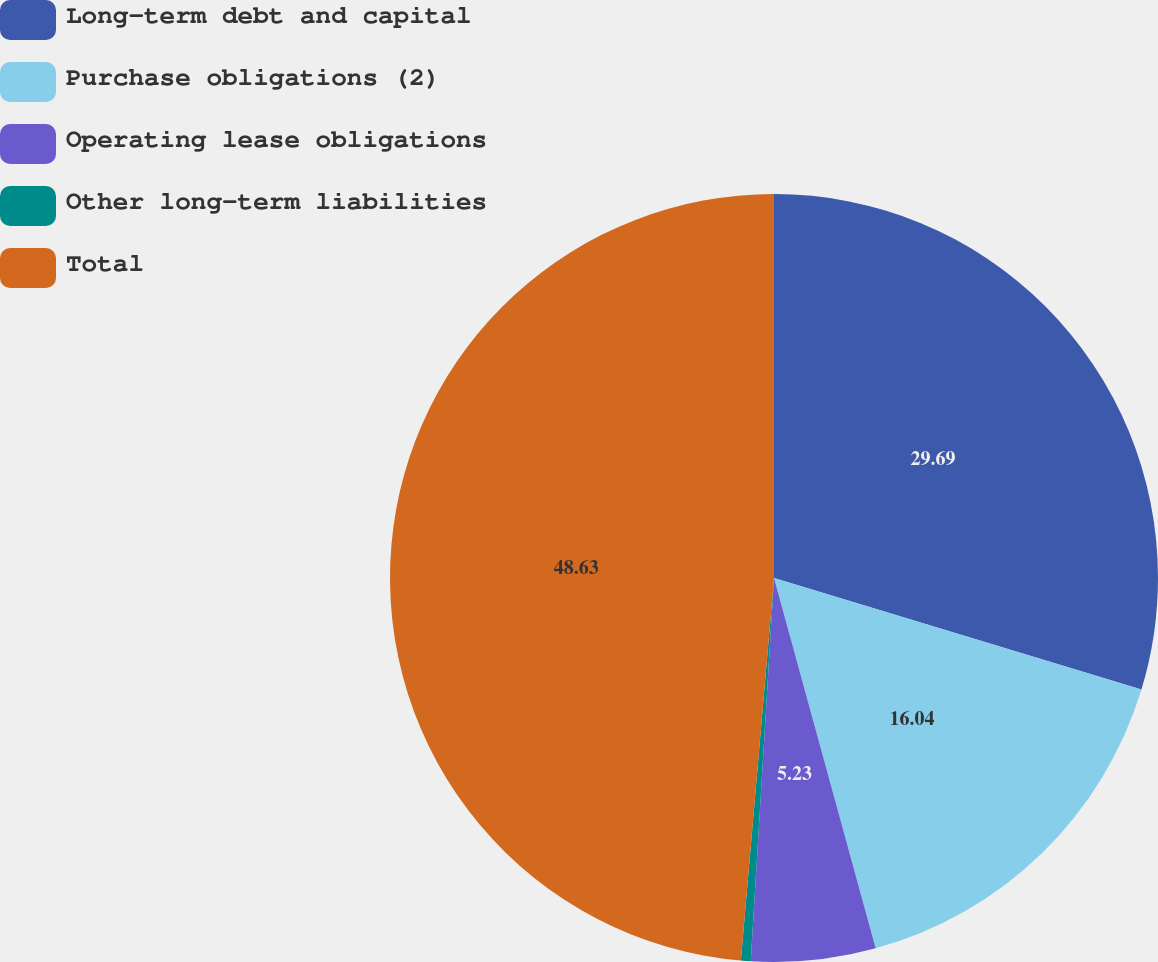<chart> <loc_0><loc_0><loc_500><loc_500><pie_chart><fcel>Long-term debt and capital<fcel>Purchase obligations (2)<fcel>Operating lease obligations<fcel>Other long-term liabilities<fcel>Total<nl><fcel>29.69%<fcel>16.04%<fcel>5.23%<fcel>0.41%<fcel>48.62%<nl></chart> 